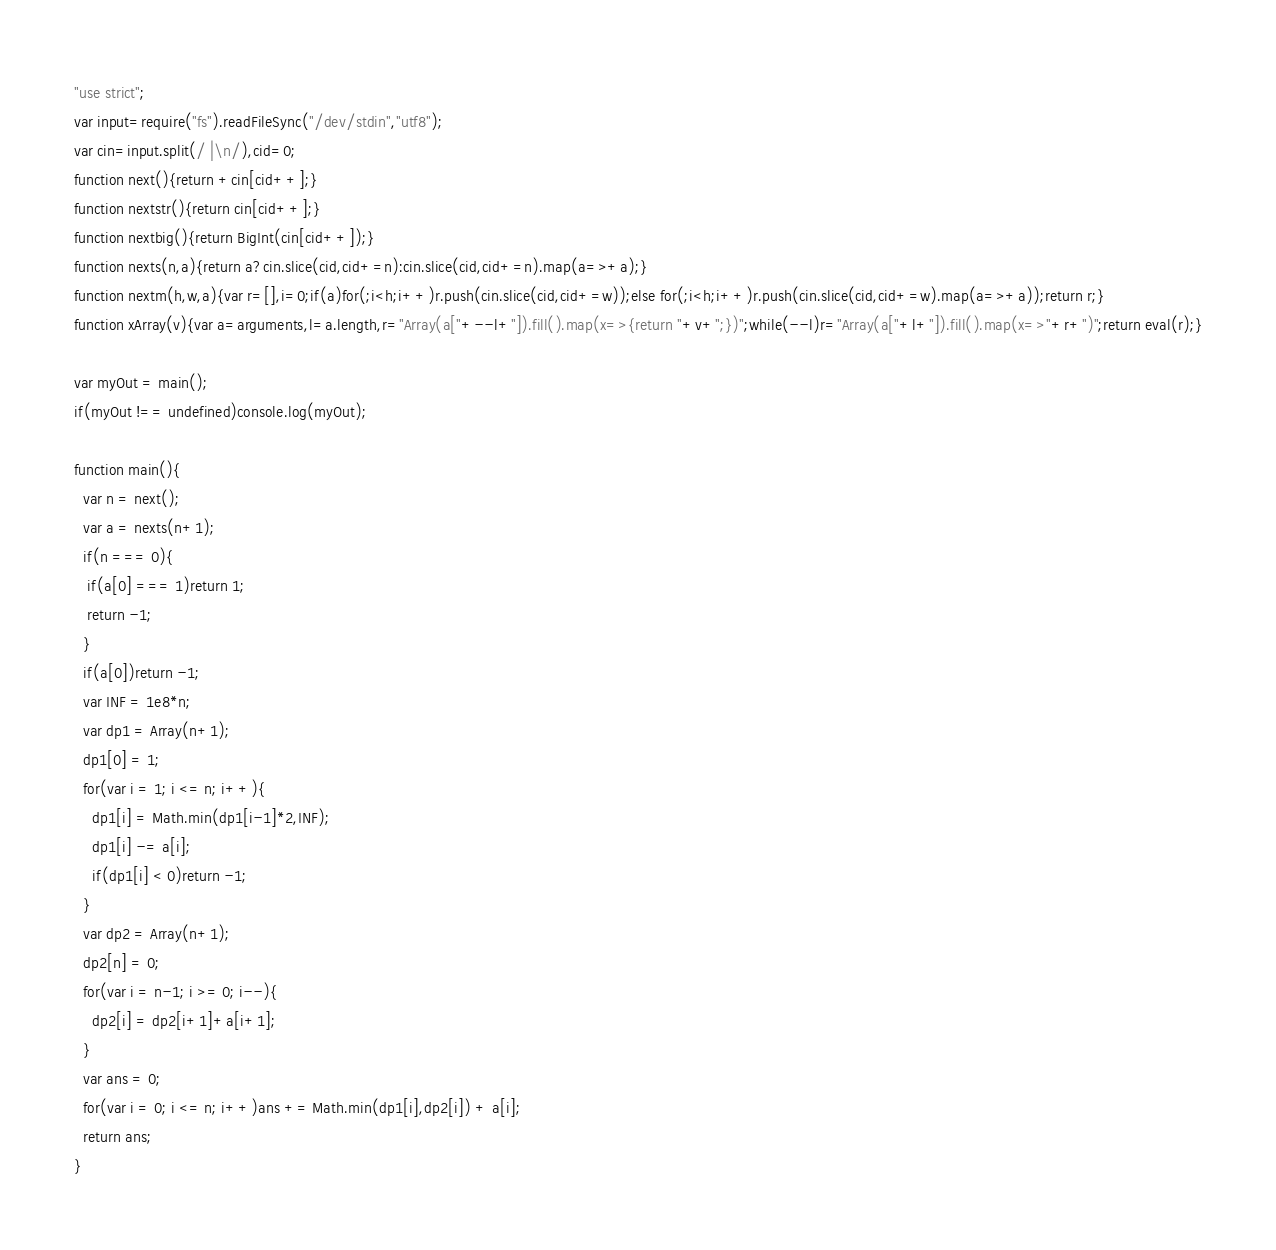Convert code to text. <code><loc_0><loc_0><loc_500><loc_500><_JavaScript_>"use strict";
var input=require("fs").readFileSync("/dev/stdin","utf8");
var cin=input.split(/ |\n/),cid=0;
function next(){return +cin[cid++];}
function nextstr(){return cin[cid++];}
function nextbig(){return BigInt(cin[cid++]);}
function nexts(n,a){return a?cin.slice(cid,cid+=n):cin.slice(cid,cid+=n).map(a=>+a);}
function nextm(h,w,a){var r=[],i=0;if(a)for(;i<h;i++)r.push(cin.slice(cid,cid+=w));else for(;i<h;i++)r.push(cin.slice(cid,cid+=w).map(a=>+a));return r;}
function xArray(v){var a=arguments,l=a.length,r="Array(a["+--l+"]).fill().map(x=>{return "+v+";})";while(--l)r="Array(a["+l+"]).fill().map(x=>"+r+")";return eval(r);}

var myOut = main();
if(myOut !== undefined)console.log(myOut);

function main(){
  var n = next();
  var a = nexts(n+1);
  if(n === 0){
   if(a[0] === 1)return 1;
   return -1;
  }
  if(a[0])return -1;
  var INF = 1e8*n;
  var dp1 = Array(n+1);
  dp1[0] = 1;
  for(var i = 1; i <= n; i++){
    dp1[i] = Math.min(dp1[i-1]*2,INF);
    dp1[i] -= a[i];
    if(dp1[i] < 0)return -1;
  }
  var dp2 = Array(n+1);
  dp2[n] = 0;
  for(var i = n-1; i >= 0; i--){
    dp2[i] = dp2[i+1]+a[i+1];
  }
  var ans = 0;
  for(var i = 0; i <= n; i++)ans += Math.min(dp1[i],dp2[i]) + a[i];
  return ans;
}</code> 